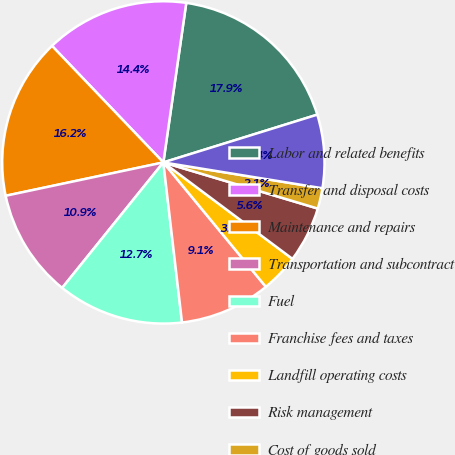Convert chart. <chart><loc_0><loc_0><loc_500><loc_500><pie_chart><fcel>Labor and related benefits<fcel>Transfer and disposal costs<fcel>Maintenance and repairs<fcel>Transportation and subcontract<fcel>Fuel<fcel>Franchise fees and taxes<fcel>Landfill operating costs<fcel>Risk management<fcel>Cost of goods sold<fcel>Other<nl><fcel>17.94%<fcel>14.41%<fcel>16.18%<fcel>10.88%<fcel>12.65%<fcel>9.12%<fcel>3.82%<fcel>5.59%<fcel>2.06%<fcel>7.35%<nl></chart> 